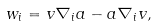<formula> <loc_0><loc_0><loc_500><loc_500>w _ { i } = v \nabla _ { i } a - a \nabla _ { i } v ,</formula> 